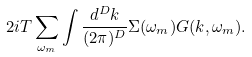<formula> <loc_0><loc_0><loc_500><loc_500>2 i T \sum _ { \omega _ { m } } \int \frac { d ^ { D } k } { ( 2 \pi ) ^ { D } } \Sigma ( \omega _ { m } ) G ( k , \omega _ { m } ) .</formula> 